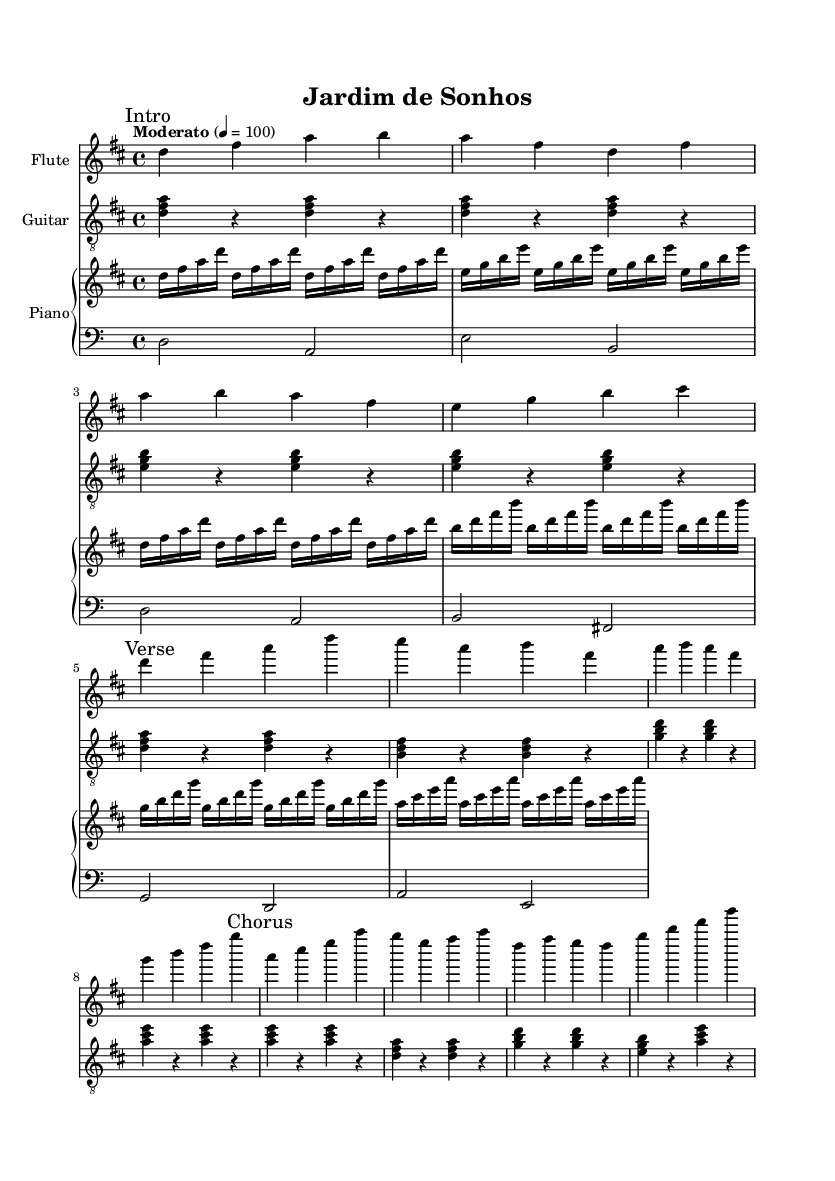What is the key signature of this music? The key signature is indicated at the beginning of the score. In this case, there are two sharps (F# and C#) which denotes D major.
Answer: D major What is the time signature of the piece? The time signature is noted right after the key signature. It shows the pattern of beats in a measure, which here is 4/4, meaning there are four beats in each measure.
Answer: 4/4 What is the tempo marking of the piece? The tempo marking is indicated above the staff. It states the speed of the music, which says "Moderato" and corresponds to a metronome marking of 100 beats per minute.
Answer: Moderato Which instrument plays the introduction? The introduction is marked in the flute part of the score. It is the first part written in the score, identified with a "Intro" mark.
Answer: Flute How many measures are in the Chorus section of the score? By counting the bars in the section labeled "Chorus," we see it consists of four measures, as delineated by the bar lines.
Answer: Four measures What chords are used in the guitar part? The guitar part includes a series of chords, specifically d major, e minor, and g major as shown by their respective notations throughout the score.
Answer: D, E minor, G What type of music is portrayed in this piece? The style of music is indicated by the overall feel, instrument choices, and performance markings. The piece is categorized as bossa nova, a Brazilian music style known for its smooth and laid-back rhythms.
Answer: Bossa nova 